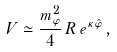Convert formula to latex. <formula><loc_0><loc_0><loc_500><loc_500>V \simeq \frac { m _ { \varphi } ^ { 2 } } { 4 } \, R \, e ^ { \kappa \hat { \varphi } } \, ,</formula> 